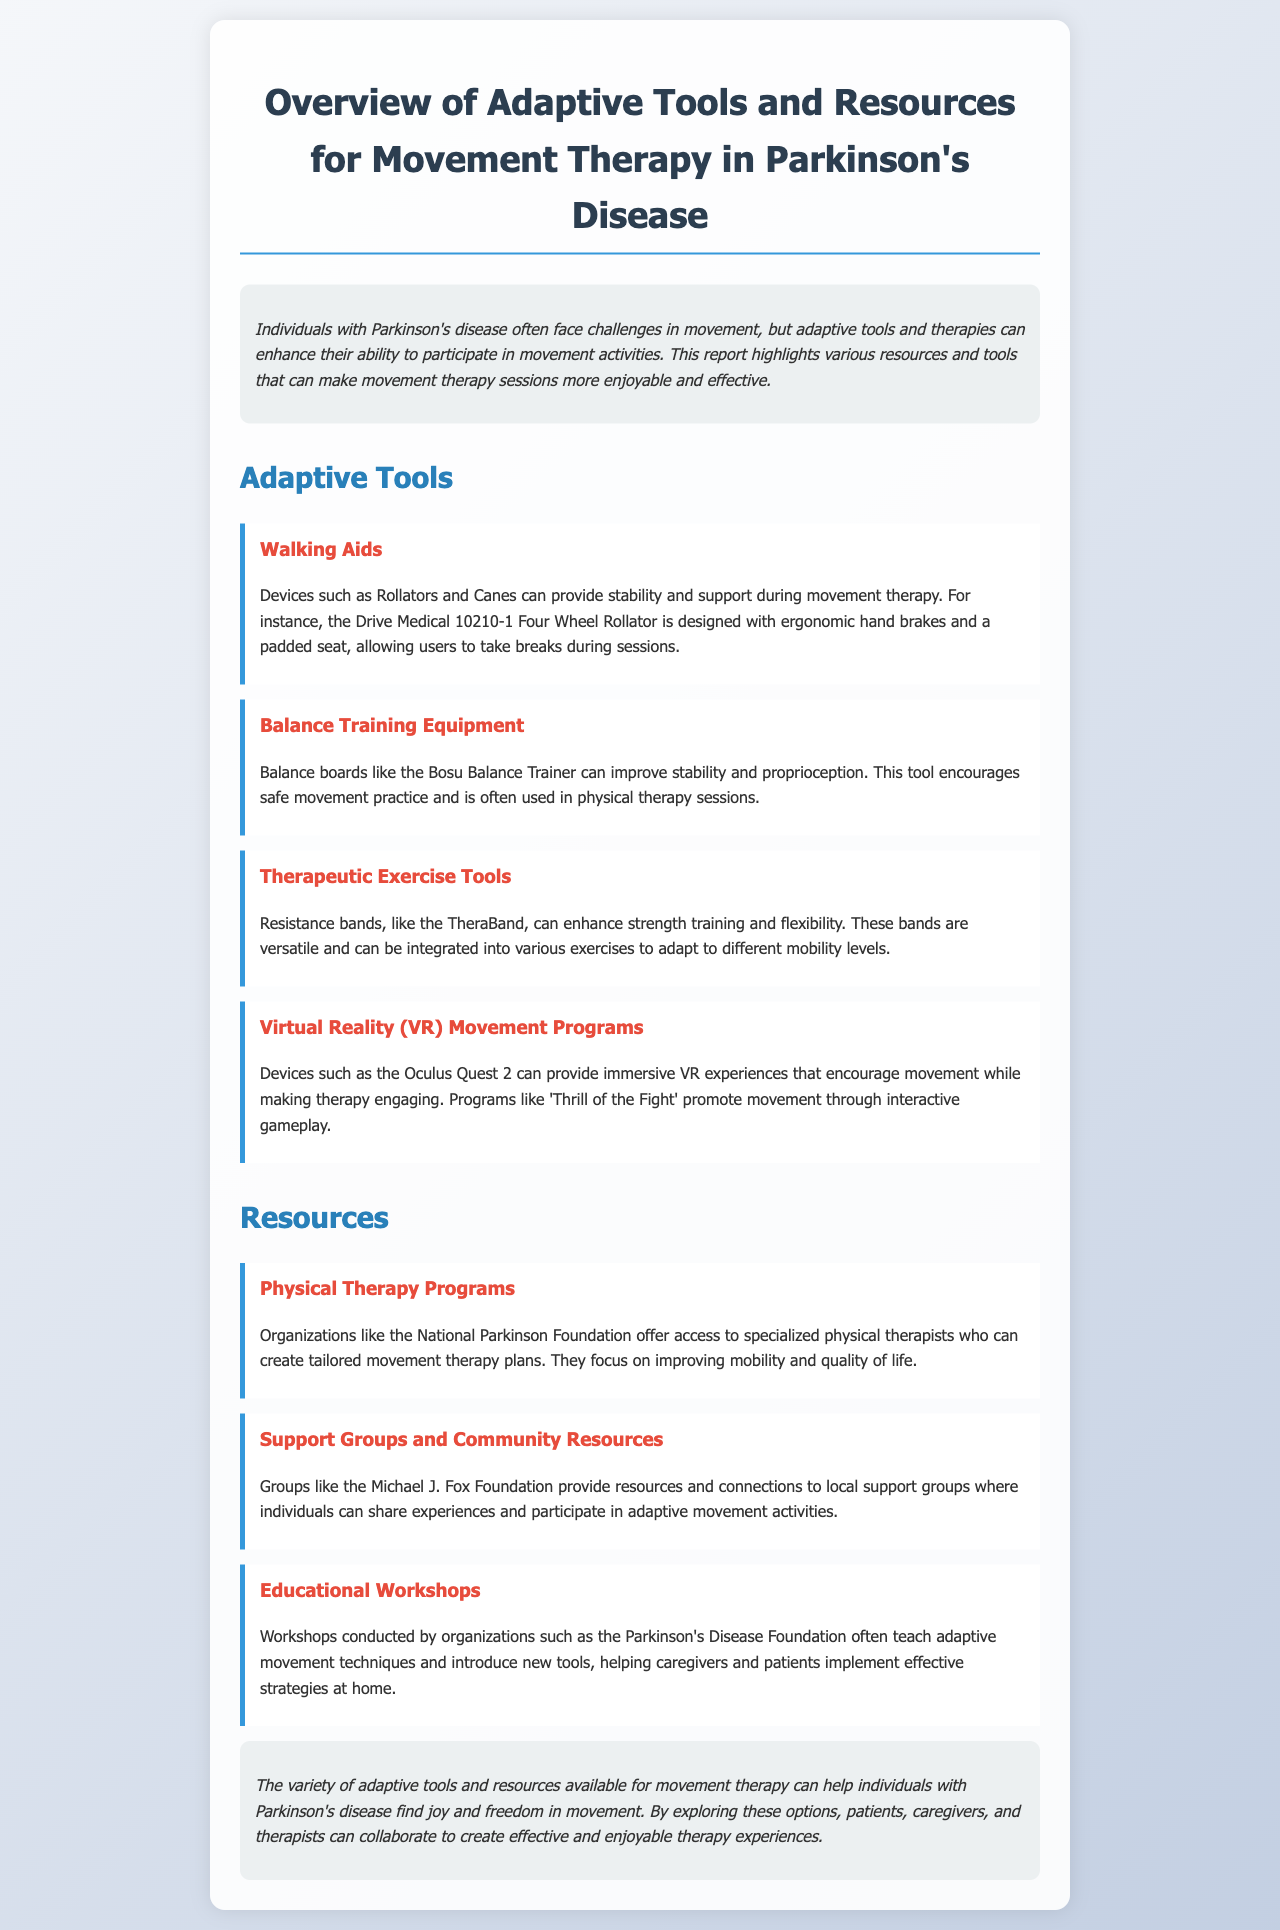What is the title of the document? The title is displayed prominently at the top of the document and provides the main topic of discussion.
Answer: Overview of Adaptive Tools and Resources for Movement Therapy in Parkinson's Disease What does VR stand for in the context of movement therapy? The document mentions VR in relation to immersive experiences in therapy.
Answer: Virtual Reality Who offers access to specialized physical therapists? This organization is mentioned as providing tailored movement therapy plans for individuals with Parkinson's disease.
Answer: National Parkinson Foundation What adaptive tool can improve stability and proprioception? This tool is specifically mentioned as a balance training equipment.
Answer: Bosu Balance Trainer What type of support does the Michael J. Fox Foundation provide? The organization is noted for its resources and local support group connections.
Answer: Support Groups and Community Resources Which tool is versatile for enhancing strength training? This tool is described in the document as useful for various exercises and mobility levels.
Answer: Resistance bands What device can provide immersive therapeutic experiences? The document lists a specific VR device used in therapy sessions.
Answer: Oculus Quest 2 What kind of workshops does the Parkinson's Disease Foundation conduct? The document mentions the purpose and focus of these workshops.
Answer: Educational Workshops How do adaptive tools impact movement therapy for people with Parkinson's disease? The conclusion summarizes the overall benefit of these tools in therapy experiences.
Answer: Joy and freedom in movement 